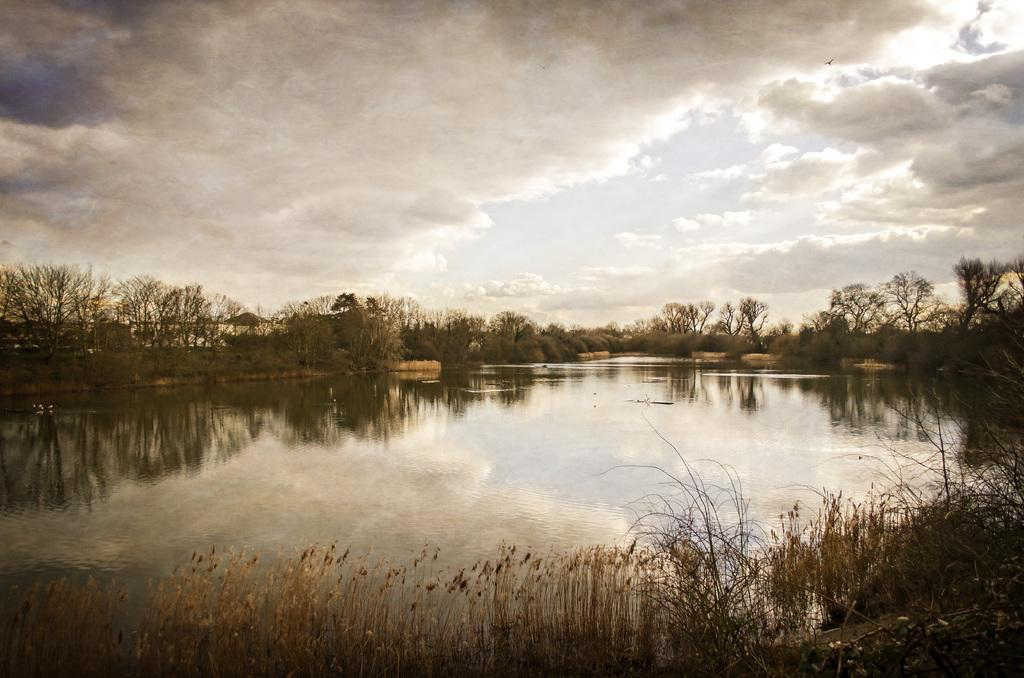What is the main feature in the image? There is a pond in the image. What type of vegetation is present around the pond? Grass plants are present around the pond. What can be seen in the background of the image? There are trees and the sky visible in the background of the image. What is the condition of the sky in the image? Clouds are present in the sky. How many rakes are being used by the beginner in the image? There is no beginner or rake present in the image. What type of feast is being prepared near the pond in the image? There is no feast or preparation visible in the image; it only features a pond, grass plants, trees, and the sky. 